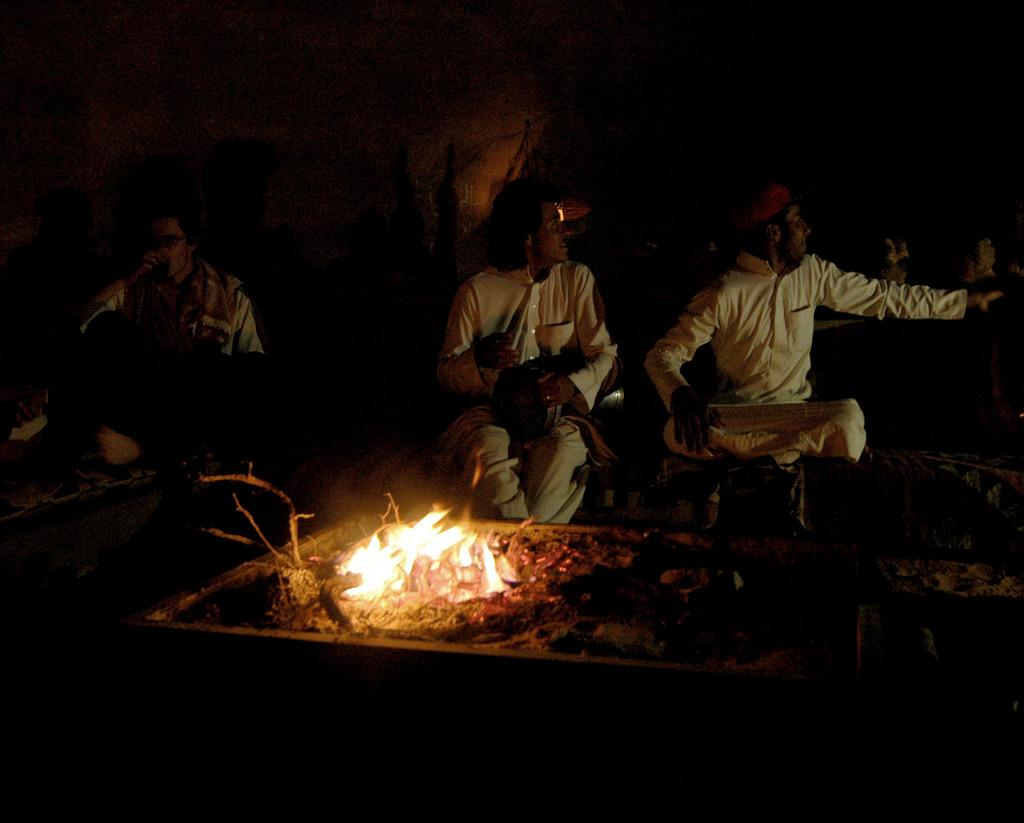What are the people in the image doing? The people in the image are sitting. What can be seen in addition to the people in the image? There is fire visible in the image, as well as other objects on the ground. How would you describe the lighting in the image? The image is dark. What type of notebook is being used by the children in the image? There are no children or notebooks present in the image. What is the current status of the fire in the image? The image does not provide information about the current status of the fire; it only shows that there is fire visible. 